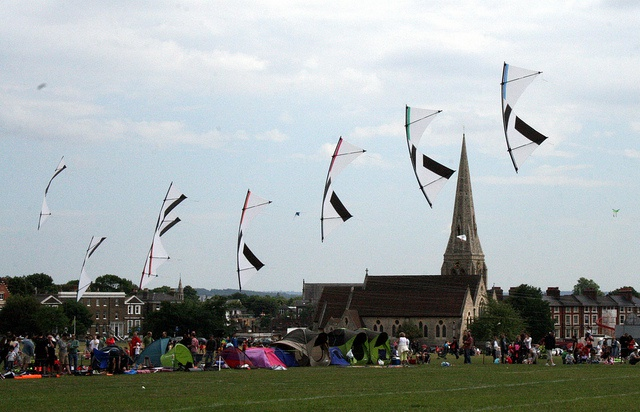Describe the objects in this image and their specific colors. I can see people in lightgray, black, gray, maroon, and darkgreen tones, kite in lightgray, black, darkgray, and gray tones, kite in lightgray, black, darkgray, and gray tones, kite in lightgray, black, darkgray, and gray tones, and kite in lightgray, black, darkgray, and gray tones in this image. 